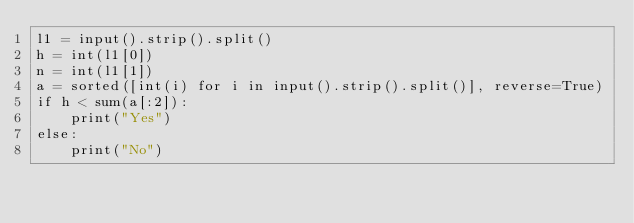<code> <loc_0><loc_0><loc_500><loc_500><_Python_>l1 = input().strip().split()
h = int(l1[0])
n = int(l1[1])
a = sorted([int(i) for i in input().strip().split()], reverse=True)
if h < sum(a[:2]):
    print("Yes")
else:
    print("No")
</code> 